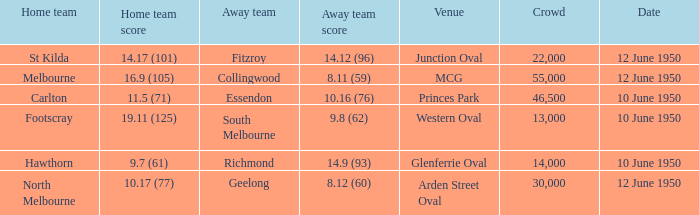What was the crowd when the VFL played MCG? 55000.0. 